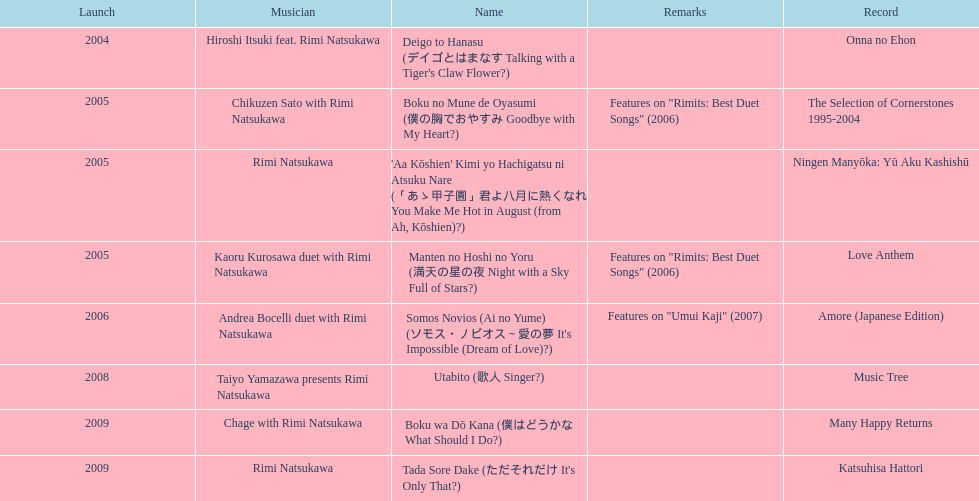What was the album released immediately before the one that had boku wa do kana on it? Music Tree. 